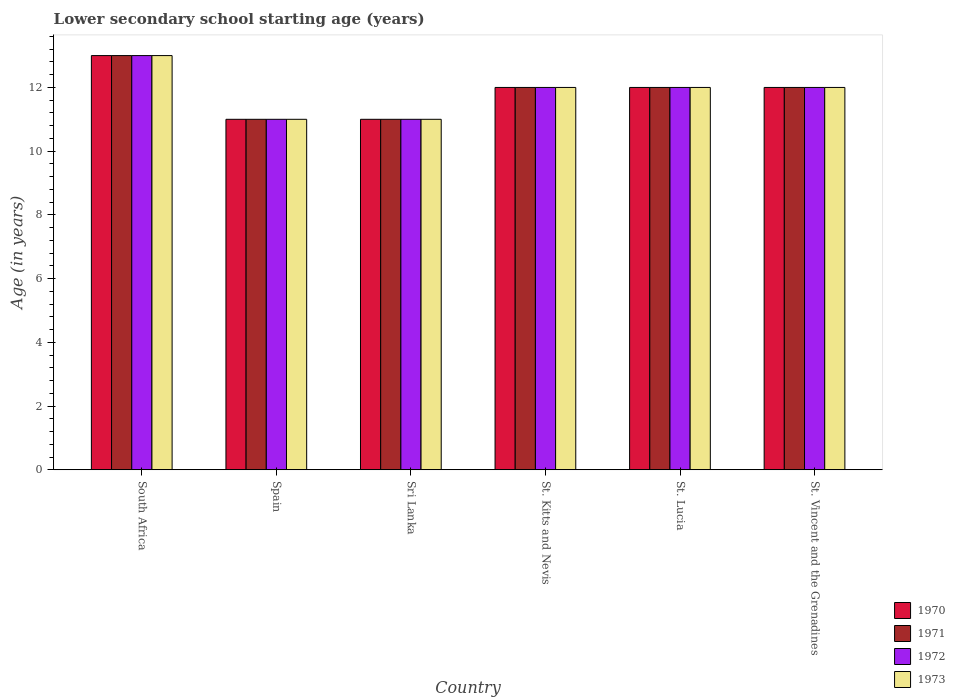Are the number of bars on each tick of the X-axis equal?
Your answer should be very brief. Yes. How many bars are there on the 2nd tick from the left?
Your answer should be compact. 4. What is the label of the 6th group of bars from the left?
Make the answer very short. St. Vincent and the Grenadines. In how many cases, is the number of bars for a given country not equal to the number of legend labels?
Your response must be concise. 0. In which country was the lower secondary school starting age of children in 1970 maximum?
Your response must be concise. South Africa. What is the total lower secondary school starting age of children in 1971 in the graph?
Keep it short and to the point. 71. What is the average lower secondary school starting age of children in 1970 per country?
Offer a terse response. 11.83. What is the difference between the lower secondary school starting age of children of/in 1971 and lower secondary school starting age of children of/in 1972 in Spain?
Make the answer very short. 0. In how many countries, is the lower secondary school starting age of children in 1972 greater than 8.8 years?
Your response must be concise. 6. What is the ratio of the lower secondary school starting age of children in 1972 in Sri Lanka to that in St. Lucia?
Your answer should be compact. 0.92. Is the lower secondary school starting age of children in 1971 in South Africa less than that in Sri Lanka?
Offer a very short reply. No. Is the difference between the lower secondary school starting age of children in 1971 in Sri Lanka and St. Lucia greater than the difference between the lower secondary school starting age of children in 1972 in Sri Lanka and St. Lucia?
Offer a very short reply. No. What is the difference between the highest and the second highest lower secondary school starting age of children in 1970?
Make the answer very short. -1. Is it the case that in every country, the sum of the lower secondary school starting age of children in 1972 and lower secondary school starting age of children in 1973 is greater than the sum of lower secondary school starting age of children in 1971 and lower secondary school starting age of children in 1970?
Your answer should be compact. No. What does the 2nd bar from the right in St. Vincent and the Grenadines represents?
Offer a very short reply. 1972. How many bars are there?
Your answer should be compact. 24. Are all the bars in the graph horizontal?
Your answer should be compact. No. What is the difference between two consecutive major ticks on the Y-axis?
Offer a very short reply. 2. Are the values on the major ticks of Y-axis written in scientific E-notation?
Ensure brevity in your answer.  No. Does the graph contain grids?
Provide a short and direct response. No. How are the legend labels stacked?
Make the answer very short. Vertical. What is the title of the graph?
Give a very brief answer. Lower secondary school starting age (years). What is the label or title of the Y-axis?
Provide a short and direct response. Age (in years). What is the Age (in years) in 1971 in Spain?
Offer a very short reply. 11. What is the Age (in years) of 1973 in Spain?
Provide a succinct answer. 11. What is the Age (in years) in 1972 in Sri Lanka?
Ensure brevity in your answer.  11. What is the Age (in years) of 1973 in Sri Lanka?
Your answer should be very brief. 11. What is the Age (in years) of 1970 in St. Kitts and Nevis?
Offer a terse response. 12. What is the Age (in years) in 1970 in St. Lucia?
Your answer should be very brief. 12. What is the Age (in years) of 1971 in St. Lucia?
Ensure brevity in your answer.  12. What is the Age (in years) of 1972 in St. Lucia?
Make the answer very short. 12. What is the Age (in years) of 1973 in St. Lucia?
Give a very brief answer. 12. What is the Age (in years) of 1970 in St. Vincent and the Grenadines?
Your response must be concise. 12. What is the Age (in years) of 1972 in St. Vincent and the Grenadines?
Ensure brevity in your answer.  12. Across all countries, what is the maximum Age (in years) of 1971?
Make the answer very short. 13. Across all countries, what is the minimum Age (in years) in 1970?
Your answer should be very brief. 11. Across all countries, what is the minimum Age (in years) of 1972?
Your answer should be very brief. 11. Across all countries, what is the minimum Age (in years) of 1973?
Make the answer very short. 11. What is the total Age (in years) in 1970 in the graph?
Give a very brief answer. 71. What is the total Age (in years) of 1972 in the graph?
Provide a short and direct response. 71. What is the difference between the Age (in years) in 1970 in South Africa and that in Spain?
Provide a short and direct response. 2. What is the difference between the Age (in years) of 1971 in South Africa and that in Spain?
Your answer should be compact. 2. What is the difference between the Age (in years) in 1970 in South Africa and that in Sri Lanka?
Offer a very short reply. 2. What is the difference between the Age (in years) in 1971 in South Africa and that in Sri Lanka?
Make the answer very short. 2. What is the difference between the Age (in years) of 1972 in South Africa and that in Sri Lanka?
Your answer should be very brief. 2. What is the difference between the Age (in years) in 1973 in South Africa and that in Sri Lanka?
Keep it short and to the point. 2. What is the difference between the Age (in years) in 1970 in South Africa and that in St. Kitts and Nevis?
Make the answer very short. 1. What is the difference between the Age (in years) of 1972 in South Africa and that in St. Kitts and Nevis?
Make the answer very short. 1. What is the difference between the Age (in years) in 1970 in South Africa and that in St. Lucia?
Provide a succinct answer. 1. What is the difference between the Age (in years) of 1972 in South Africa and that in St. Lucia?
Provide a succinct answer. 1. What is the difference between the Age (in years) in 1970 in South Africa and that in St. Vincent and the Grenadines?
Your answer should be very brief. 1. What is the difference between the Age (in years) in 1971 in South Africa and that in St. Vincent and the Grenadines?
Offer a very short reply. 1. What is the difference between the Age (in years) of 1970 in Spain and that in Sri Lanka?
Your answer should be compact. 0. What is the difference between the Age (in years) of 1972 in Spain and that in Sri Lanka?
Provide a short and direct response. 0. What is the difference between the Age (in years) of 1973 in Spain and that in Sri Lanka?
Offer a very short reply. 0. What is the difference between the Age (in years) in 1970 in Spain and that in St. Kitts and Nevis?
Provide a succinct answer. -1. What is the difference between the Age (in years) in 1971 in Spain and that in St. Kitts and Nevis?
Offer a very short reply. -1. What is the difference between the Age (in years) of 1972 in Spain and that in St. Kitts and Nevis?
Provide a succinct answer. -1. What is the difference between the Age (in years) of 1973 in Spain and that in St. Kitts and Nevis?
Provide a succinct answer. -1. What is the difference between the Age (in years) in 1970 in Spain and that in St. Lucia?
Offer a terse response. -1. What is the difference between the Age (in years) of 1972 in Spain and that in St. Lucia?
Offer a terse response. -1. What is the difference between the Age (in years) of 1973 in Spain and that in St. Lucia?
Make the answer very short. -1. What is the difference between the Age (in years) in 1971 in Spain and that in St. Vincent and the Grenadines?
Ensure brevity in your answer.  -1. What is the difference between the Age (in years) in 1973 in Spain and that in St. Vincent and the Grenadines?
Provide a short and direct response. -1. What is the difference between the Age (in years) of 1971 in Sri Lanka and that in St. Kitts and Nevis?
Give a very brief answer. -1. What is the difference between the Age (in years) in 1972 in Sri Lanka and that in St. Kitts and Nevis?
Your response must be concise. -1. What is the difference between the Age (in years) of 1973 in Sri Lanka and that in St. Kitts and Nevis?
Give a very brief answer. -1. What is the difference between the Age (in years) in 1973 in Sri Lanka and that in St. Lucia?
Provide a succinct answer. -1. What is the difference between the Age (in years) in 1970 in Sri Lanka and that in St. Vincent and the Grenadines?
Offer a very short reply. -1. What is the difference between the Age (in years) of 1972 in Sri Lanka and that in St. Vincent and the Grenadines?
Your answer should be very brief. -1. What is the difference between the Age (in years) in 1973 in Sri Lanka and that in St. Vincent and the Grenadines?
Offer a very short reply. -1. What is the difference between the Age (in years) of 1970 in St. Kitts and Nevis and that in St. Lucia?
Keep it short and to the point. 0. What is the difference between the Age (in years) of 1971 in St. Kitts and Nevis and that in St. Lucia?
Provide a succinct answer. 0. What is the difference between the Age (in years) in 1972 in St. Kitts and Nevis and that in St. Lucia?
Give a very brief answer. 0. What is the difference between the Age (in years) of 1971 in St. Kitts and Nevis and that in St. Vincent and the Grenadines?
Provide a succinct answer. 0. What is the difference between the Age (in years) in 1973 in St. Kitts and Nevis and that in St. Vincent and the Grenadines?
Your response must be concise. 0. What is the difference between the Age (in years) in 1972 in St. Lucia and that in St. Vincent and the Grenadines?
Give a very brief answer. 0. What is the difference between the Age (in years) in 1973 in St. Lucia and that in St. Vincent and the Grenadines?
Your answer should be compact. 0. What is the difference between the Age (in years) in 1970 in South Africa and the Age (in years) in 1972 in Spain?
Ensure brevity in your answer.  2. What is the difference between the Age (in years) in 1971 in South Africa and the Age (in years) in 1972 in Spain?
Keep it short and to the point. 2. What is the difference between the Age (in years) of 1971 in South Africa and the Age (in years) of 1973 in Spain?
Offer a very short reply. 2. What is the difference between the Age (in years) in 1972 in South Africa and the Age (in years) in 1973 in Spain?
Give a very brief answer. 2. What is the difference between the Age (in years) of 1970 in South Africa and the Age (in years) of 1971 in Sri Lanka?
Provide a succinct answer. 2. What is the difference between the Age (in years) of 1971 in South Africa and the Age (in years) of 1972 in Sri Lanka?
Your response must be concise. 2. What is the difference between the Age (in years) of 1971 in South Africa and the Age (in years) of 1972 in St. Kitts and Nevis?
Offer a terse response. 1. What is the difference between the Age (in years) of 1971 in South Africa and the Age (in years) of 1973 in St. Kitts and Nevis?
Ensure brevity in your answer.  1. What is the difference between the Age (in years) in 1970 in South Africa and the Age (in years) in 1971 in St. Lucia?
Provide a succinct answer. 1. What is the difference between the Age (in years) of 1970 in South Africa and the Age (in years) of 1972 in St. Lucia?
Provide a succinct answer. 1. What is the difference between the Age (in years) in 1971 in South Africa and the Age (in years) in 1972 in St. Lucia?
Your response must be concise. 1. What is the difference between the Age (in years) in 1971 in South Africa and the Age (in years) in 1973 in St. Lucia?
Give a very brief answer. 1. What is the difference between the Age (in years) in 1970 in South Africa and the Age (in years) in 1972 in St. Vincent and the Grenadines?
Offer a terse response. 1. What is the difference between the Age (in years) of 1970 in South Africa and the Age (in years) of 1973 in St. Vincent and the Grenadines?
Your answer should be compact. 1. What is the difference between the Age (in years) of 1970 in Spain and the Age (in years) of 1971 in Sri Lanka?
Keep it short and to the point. 0. What is the difference between the Age (in years) in 1971 in Spain and the Age (in years) in 1972 in Sri Lanka?
Provide a succinct answer. 0. What is the difference between the Age (in years) in 1971 in Spain and the Age (in years) in 1973 in Sri Lanka?
Provide a short and direct response. 0. What is the difference between the Age (in years) of 1972 in Spain and the Age (in years) of 1973 in Sri Lanka?
Offer a terse response. 0. What is the difference between the Age (in years) in 1970 in Spain and the Age (in years) in 1971 in St. Kitts and Nevis?
Give a very brief answer. -1. What is the difference between the Age (in years) of 1971 in Spain and the Age (in years) of 1972 in St. Kitts and Nevis?
Your response must be concise. -1. What is the difference between the Age (in years) of 1971 in Spain and the Age (in years) of 1973 in St. Kitts and Nevis?
Ensure brevity in your answer.  -1. What is the difference between the Age (in years) of 1970 in Spain and the Age (in years) of 1971 in St. Lucia?
Offer a terse response. -1. What is the difference between the Age (in years) of 1970 in Spain and the Age (in years) of 1972 in St. Lucia?
Provide a short and direct response. -1. What is the difference between the Age (in years) in 1970 in Spain and the Age (in years) in 1971 in St. Vincent and the Grenadines?
Offer a terse response. -1. What is the difference between the Age (in years) of 1970 in Spain and the Age (in years) of 1973 in St. Vincent and the Grenadines?
Offer a terse response. -1. What is the difference between the Age (in years) of 1971 in Spain and the Age (in years) of 1972 in St. Vincent and the Grenadines?
Your response must be concise. -1. What is the difference between the Age (in years) of 1971 in Spain and the Age (in years) of 1973 in St. Vincent and the Grenadines?
Provide a succinct answer. -1. What is the difference between the Age (in years) of 1972 in Spain and the Age (in years) of 1973 in St. Vincent and the Grenadines?
Your answer should be compact. -1. What is the difference between the Age (in years) of 1970 in Sri Lanka and the Age (in years) of 1971 in St. Kitts and Nevis?
Ensure brevity in your answer.  -1. What is the difference between the Age (in years) in 1970 in Sri Lanka and the Age (in years) in 1972 in St. Kitts and Nevis?
Give a very brief answer. -1. What is the difference between the Age (in years) in 1970 in Sri Lanka and the Age (in years) in 1973 in St. Kitts and Nevis?
Your answer should be very brief. -1. What is the difference between the Age (in years) in 1971 in Sri Lanka and the Age (in years) in 1973 in St. Kitts and Nevis?
Offer a terse response. -1. What is the difference between the Age (in years) in 1972 in Sri Lanka and the Age (in years) in 1973 in St. Kitts and Nevis?
Keep it short and to the point. -1. What is the difference between the Age (in years) in 1971 in Sri Lanka and the Age (in years) in 1972 in St. Lucia?
Your response must be concise. -1. What is the difference between the Age (in years) of 1971 in Sri Lanka and the Age (in years) of 1973 in St. Lucia?
Ensure brevity in your answer.  -1. What is the difference between the Age (in years) of 1971 in Sri Lanka and the Age (in years) of 1973 in St. Vincent and the Grenadines?
Offer a very short reply. -1. What is the difference between the Age (in years) in 1972 in Sri Lanka and the Age (in years) in 1973 in St. Vincent and the Grenadines?
Your response must be concise. -1. What is the difference between the Age (in years) of 1970 in St. Kitts and Nevis and the Age (in years) of 1971 in St. Lucia?
Provide a short and direct response. 0. What is the difference between the Age (in years) of 1971 in St. Kitts and Nevis and the Age (in years) of 1972 in St. Lucia?
Provide a short and direct response. 0. What is the difference between the Age (in years) in 1970 in St. Kitts and Nevis and the Age (in years) in 1972 in St. Vincent and the Grenadines?
Your answer should be compact. 0. What is the difference between the Age (in years) in 1970 in St. Kitts and Nevis and the Age (in years) in 1973 in St. Vincent and the Grenadines?
Your answer should be compact. 0. What is the difference between the Age (in years) of 1971 in St. Kitts and Nevis and the Age (in years) of 1972 in St. Vincent and the Grenadines?
Keep it short and to the point. 0. What is the difference between the Age (in years) in 1971 in St. Kitts and Nevis and the Age (in years) in 1973 in St. Vincent and the Grenadines?
Offer a very short reply. 0. What is the difference between the Age (in years) in 1970 in St. Lucia and the Age (in years) in 1973 in St. Vincent and the Grenadines?
Offer a terse response. 0. What is the difference between the Age (in years) of 1971 in St. Lucia and the Age (in years) of 1972 in St. Vincent and the Grenadines?
Keep it short and to the point. 0. What is the average Age (in years) of 1970 per country?
Provide a short and direct response. 11.83. What is the average Age (in years) of 1971 per country?
Provide a short and direct response. 11.83. What is the average Age (in years) in 1972 per country?
Your answer should be very brief. 11.83. What is the average Age (in years) of 1973 per country?
Your answer should be compact. 11.83. What is the difference between the Age (in years) in 1970 and Age (in years) in 1971 in Spain?
Keep it short and to the point. 0. What is the difference between the Age (in years) of 1971 and Age (in years) of 1972 in Spain?
Provide a short and direct response. 0. What is the difference between the Age (in years) in 1972 and Age (in years) in 1973 in Spain?
Provide a succinct answer. 0. What is the difference between the Age (in years) of 1970 and Age (in years) of 1971 in Sri Lanka?
Keep it short and to the point. 0. What is the difference between the Age (in years) in 1970 and Age (in years) in 1972 in Sri Lanka?
Make the answer very short. 0. What is the difference between the Age (in years) of 1970 and Age (in years) of 1973 in Sri Lanka?
Keep it short and to the point. 0. What is the difference between the Age (in years) in 1971 and Age (in years) in 1972 in Sri Lanka?
Your response must be concise. 0. What is the difference between the Age (in years) in 1971 and Age (in years) in 1973 in Sri Lanka?
Your answer should be compact. 0. What is the difference between the Age (in years) in 1970 and Age (in years) in 1973 in St. Kitts and Nevis?
Ensure brevity in your answer.  0. What is the difference between the Age (in years) in 1971 and Age (in years) in 1972 in St. Kitts and Nevis?
Provide a succinct answer. 0. What is the difference between the Age (in years) of 1970 and Age (in years) of 1973 in St. Lucia?
Offer a very short reply. 0. What is the difference between the Age (in years) of 1971 and Age (in years) of 1973 in St. Lucia?
Give a very brief answer. 0. What is the difference between the Age (in years) in 1972 and Age (in years) in 1973 in St. Lucia?
Ensure brevity in your answer.  0. What is the difference between the Age (in years) in 1970 and Age (in years) in 1971 in St. Vincent and the Grenadines?
Give a very brief answer. 0. What is the difference between the Age (in years) of 1970 and Age (in years) of 1972 in St. Vincent and the Grenadines?
Offer a very short reply. 0. What is the difference between the Age (in years) in 1970 and Age (in years) in 1973 in St. Vincent and the Grenadines?
Give a very brief answer. 0. What is the difference between the Age (in years) in 1971 and Age (in years) in 1972 in St. Vincent and the Grenadines?
Offer a very short reply. 0. What is the ratio of the Age (in years) in 1970 in South Africa to that in Spain?
Provide a succinct answer. 1.18. What is the ratio of the Age (in years) of 1971 in South Africa to that in Spain?
Your answer should be very brief. 1.18. What is the ratio of the Age (in years) of 1972 in South Africa to that in Spain?
Your response must be concise. 1.18. What is the ratio of the Age (in years) in 1973 in South Africa to that in Spain?
Provide a succinct answer. 1.18. What is the ratio of the Age (in years) in 1970 in South Africa to that in Sri Lanka?
Provide a succinct answer. 1.18. What is the ratio of the Age (in years) in 1971 in South Africa to that in Sri Lanka?
Your response must be concise. 1.18. What is the ratio of the Age (in years) of 1972 in South Africa to that in Sri Lanka?
Offer a terse response. 1.18. What is the ratio of the Age (in years) of 1973 in South Africa to that in Sri Lanka?
Your answer should be very brief. 1.18. What is the ratio of the Age (in years) of 1970 in South Africa to that in St. Kitts and Nevis?
Give a very brief answer. 1.08. What is the ratio of the Age (in years) of 1971 in South Africa to that in St. Kitts and Nevis?
Ensure brevity in your answer.  1.08. What is the ratio of the Age (in years) in 1972 in South Africa to that in St. Lucia?
Offer a very short reply. 1.08. What is the ratio of the Age (in years) in 1972 in South Africa to that in St. Vincent and the Grenadines?
Provide a short and direct response. 1.08. What is the ratio of the Age (in years) of 1971 in Spain to that in Sri Lanka?
Give a very brief answer. 1. What is the ratio of the Age (in years) in 1972 in Spain to that in Sri Lanka?
Your response must be concise. 1. What is the ratio of the Age (in years) in 1970 in Spain to that in St. Kitts and Nevis?
Make the answer very short. 0.92. What is the ratio of the Age (in years) of 1971 in Spain to that in St. Kitts and Nevis?
Give a very brief answer. 0.92. What is the ratio of the Age (in years) of 1972 in Spain to that in St. Kitts and Nevis?
Make the answer very short. 0.92. What is the ratio of the Age (in years) of 1970 in Spain to that in St. Lucia?
Provide a succinct answer. 0.92. What is the ratio of the Age (in years) in 1973 in Spain to that in St. Lucia?
Give a very brief answer. 0.92. What is the ratio of the Age (in years) in 1970 in Spain to that in St. Vincent and the Grenadines?
Your answer should be very brief. 0.92. What is the ratio of the Age (in years) in 1972 in Spain to that in St. Vincent and the Grenadines?
Your answer should be very brief. 0.92. What is the ratio of the Age (in years) of 1970 in Sri Lanka to that in St. Kitts and Nevis?
Provide a short and direct response. 0.92. What is the ratio of the Age (in years) in 1971 in Sri Lanka to that in St. Kitts and Nevis?
Make the answer very short. 0.92. What is the ratio of the Age (in years) in 1973 in Sri Lanka to that in St. Kitts and Nevis?
Your response must be concise. 0.92. What is the ratio of the Age (in years) of 1970 in Sri Lanka to that in St. Lucia?
Your answer should be very brief. 0.92. What is the ratio of the Age (in years) of 1972 in Sri Lanka to that in St. Vincent and the Grenadines?
Your answer should be compact. 0.92. What is the ratio of the Age (in years) of 1972 in St. Kitts and Nevis to that in St. Lucia?
Give a very brief answer. 1. What is the ratio of the Age (in years) of 1971 in St. Lucia to that in St. Vincent and the Grenadines?
Ensure brevity in your answer.  1. What is the ratio of the Age (in years) of 1973 in St. Lucia to that in St. Vincent and the Grenadines?
Your answer should be compact. 1. What is the difference between the highest and the second highest Age (in years) of 1971?
Your answer should be very brief. 1. What is the difference between the highest and the second highest Age (in years) of 1973?
Your response must be concise. 1. 